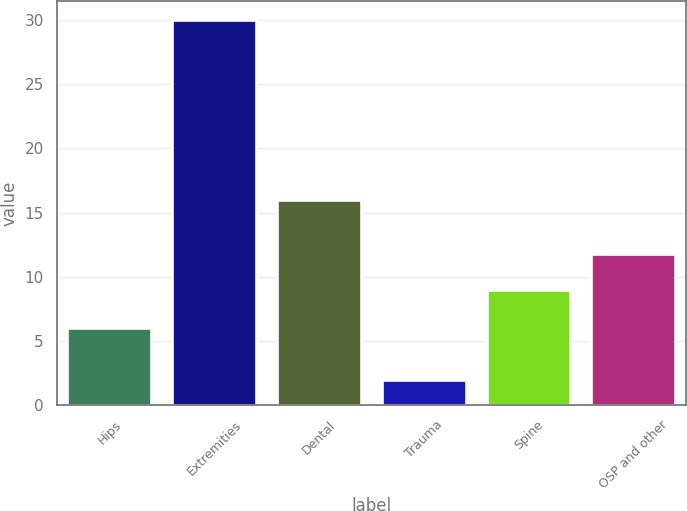<chart> <loc_0><loc_0><loc_500><loc_500><bar_chart><fcel>Hips<fcel>Extremities<fcel>Dental<fcel>Trauma<fcel>Spine<fcel>OSP and other<nl><fcel>6<fcel>30<fcel>16<fcel>2<fcel>9<fcel>11.8<nl></chart> 